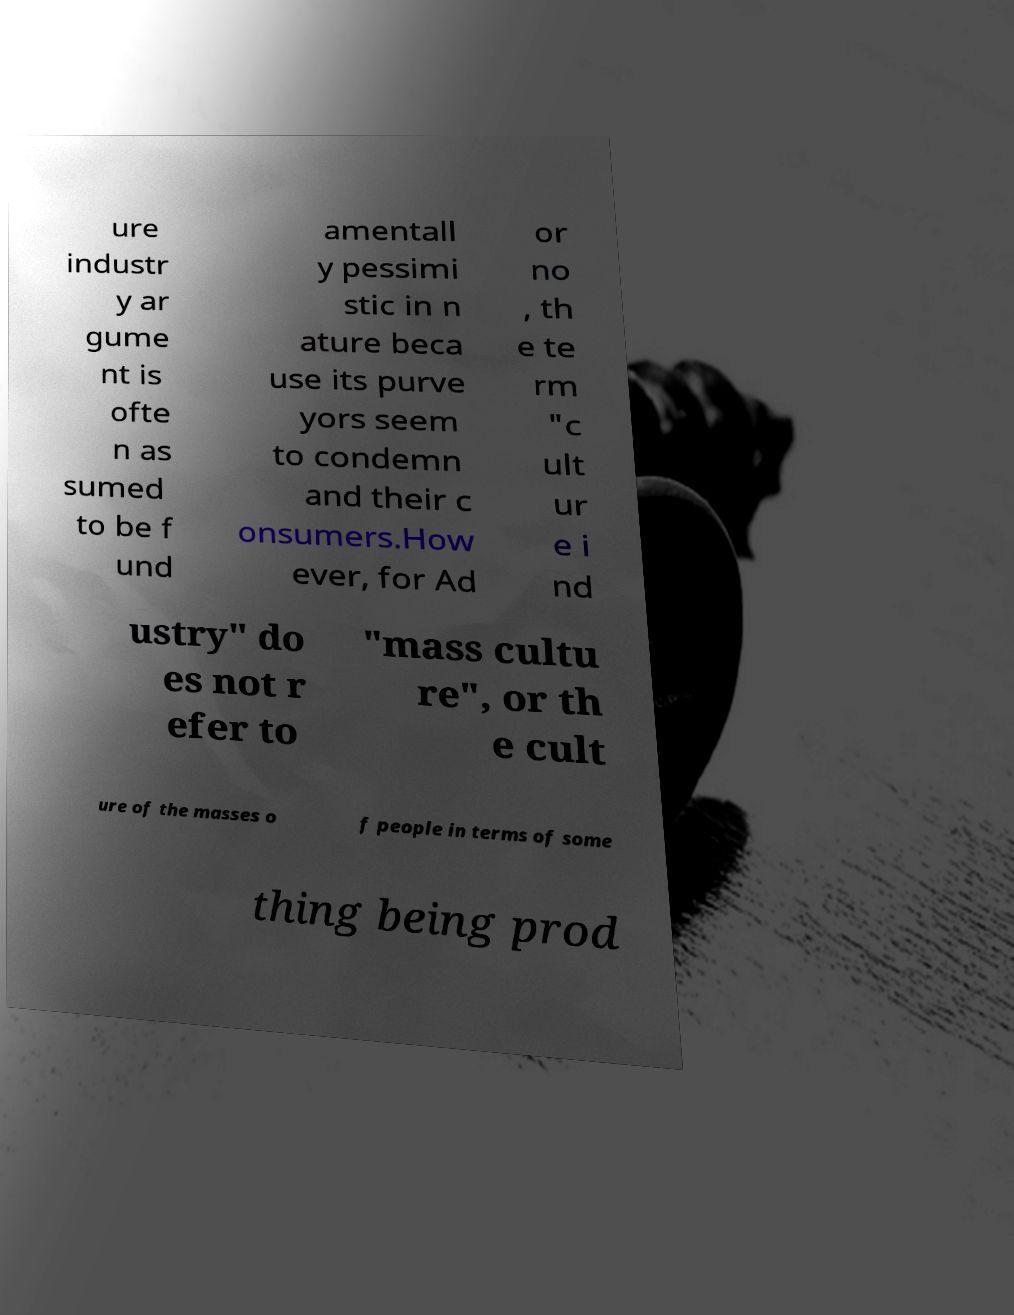Could you extract and type out the text from this image? ure industr y ar gume nt is ofte n as sumed to be f und amentall y pessimi stic in n ature beca use its purve yors seem to condemn and their c onsumers.How ever, for Ad or no , th e te rm "c ult ur e i nd ustry" do es not r efer to "mass cultu re", or th e cult ure of the masses o f people in terms of some thing being prod 